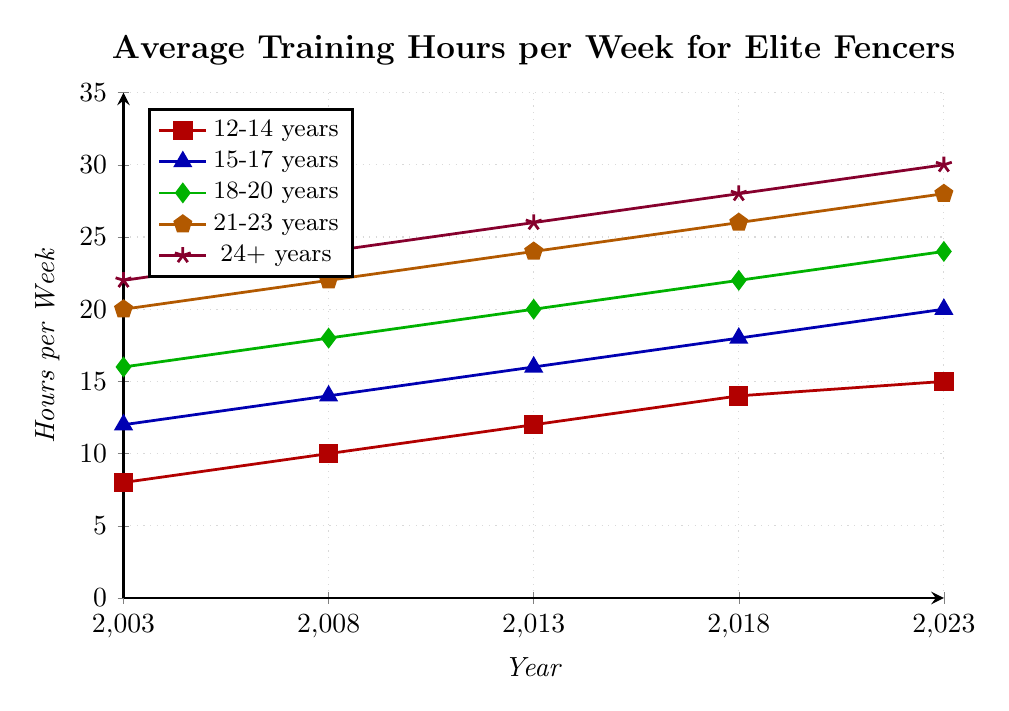Which age group had the highest average training hours per week in 2023? The 24+ years group had the highest average training hours per week at 30 hours, as indicated by the highest point on the plot for 2023.
Answer: 24+ years How did the average training hours for the 18-20 years age group change from 2003 to 2023? The 18-20 years age group started at 16 hours in 2003 and increased to 24 hours in 2023. This is a change of 24 - 16 = 8 hours.
Answer: 8 hours What is the overall trend in training hours for the 12-14 years age group over the 20-year period? The 12-14 years age group shows a general increasing trend in training hours, starting at 8 hours in 2003 and reaching 15 hours in 2023.
Answer: Increasing Compare the training hours for the 21-23 years and 24+ years age groups in 2013. Which group had more training hours, and by how much? In 2013, the 21-23 years group had 24 hours of training, while the 24+ years group had 26 hours. The difference is 26 - 24 = 2 hours.
Answer: 24+, 2 hours Which age group showed the least increase in average training hours per week from 2003 to 2023? The 12-14 years group increased from 8 to 15 hours, which is a 7-hour increase; this is less than the increases in any other age group.
Answer: 12-14 years What are the average training hours per week for the 15-17 years age group in 2018? The average training hours for the 15-17 years age group in 2018 is 18 hours, as marked on the plot.
Answer: 18 hours By how many hours did the training hours for the 24+ years group increase from 2003 to 2018? The training hours for the 24+ years group increased from 22 hours in 2003 to 28 hours in 2018. The increase is 28 - 22 = 6 hours.
Answer: 6 hours Which age group and year combination shows the minimum training hours in the entire dataset? The 12-14 years group in 2003 shows the minimum training hours with 8 hours.
Answer: 12-14 years, 2003 